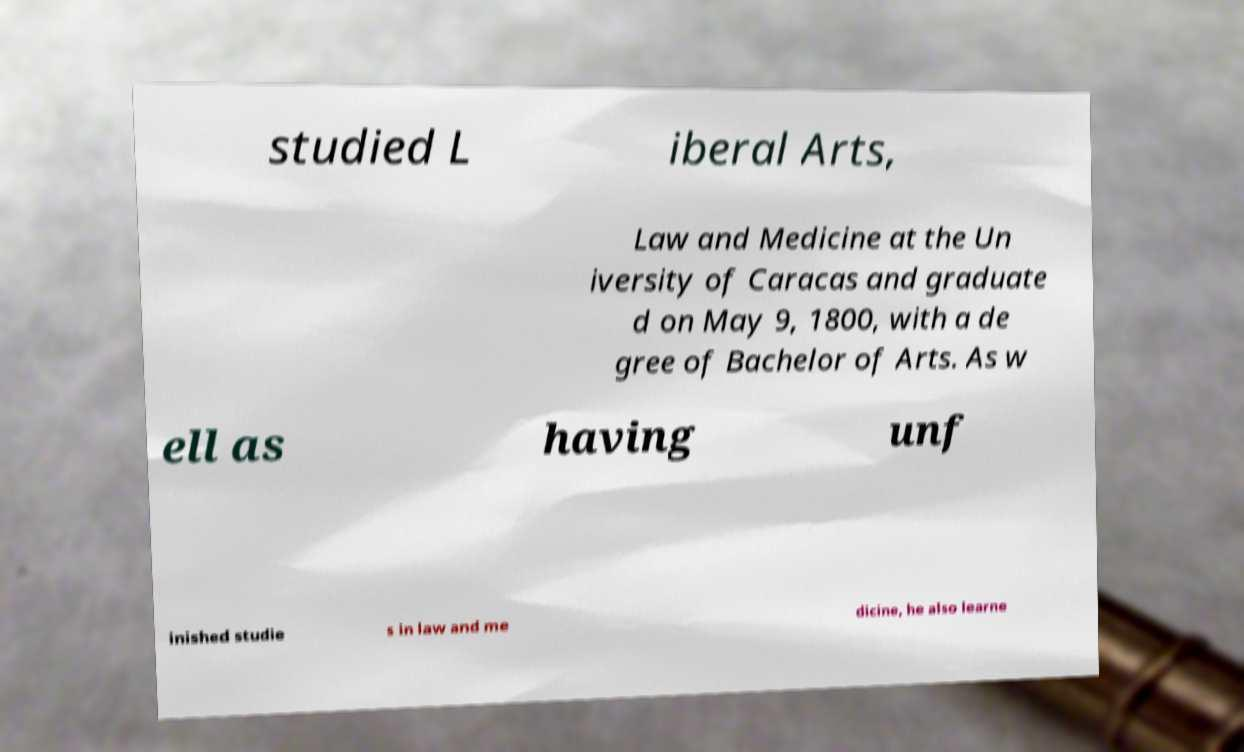For documentation purposes, I need the text within this image transcribed. Could you provide that? studied L iberal Arts, Law and Medicine at the Un iversity of Caracas and graduate d on May 9, 1800, with a de gree of Bachelor of Arts. As w ell as having unf inished studie s in law and me dicine, he also learne 